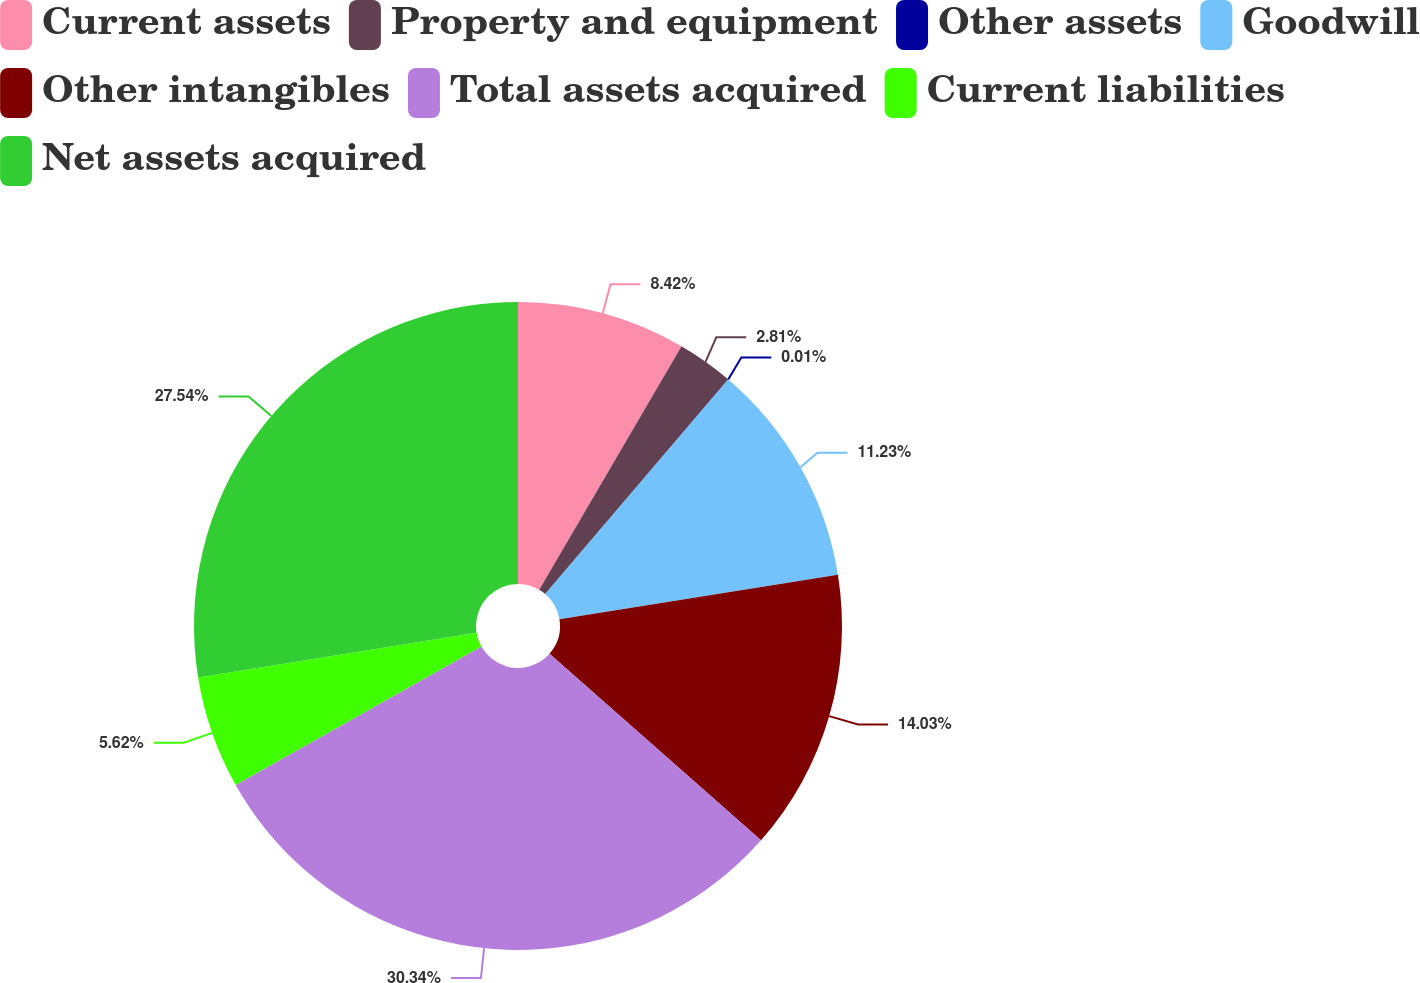Convert chart to OTSL. <chart><loc_0><loc_0><loc_500><loc_500><pie_chart><fcel>Current assets<fcel>Property and equipment<fcel>Other assets<fcel>Goodwill<fcel>Other intangibles<fcel>Total assets acquired<fcel>Current liabilities<fcel>Net assets acquired<nl><fcel>8.42%<fcel>2.81%<fcel>0.01%<fcel>11.23%<fcel>14.03%<fcel>30.34%<fcel>5.62%<fcel>27.54%<nl></chart> 